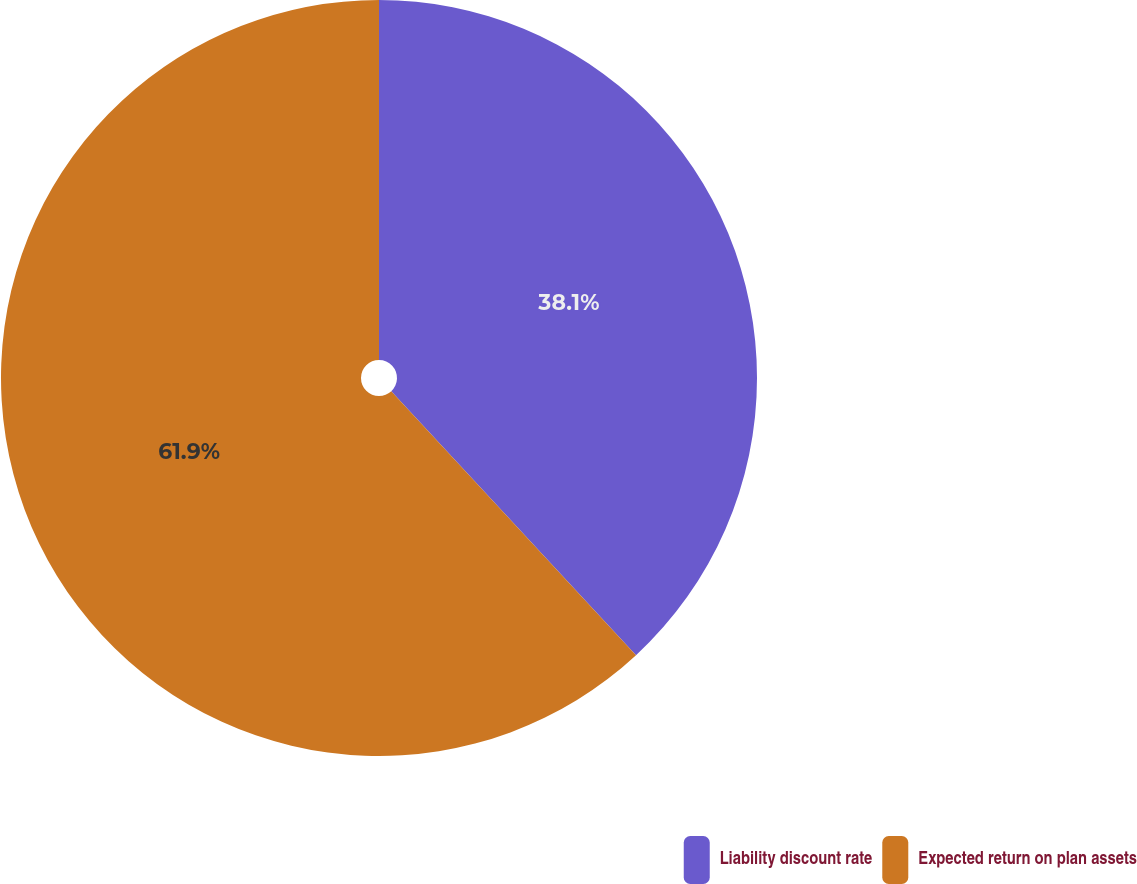<chart> <loc_0><loc_0><loc_500><loc_500><pie_chart><fcel>Liability discount rate<fcel>Expected return on plan assets<nl><fcel>38.1%<fcel>61.9%<nl></chart> 